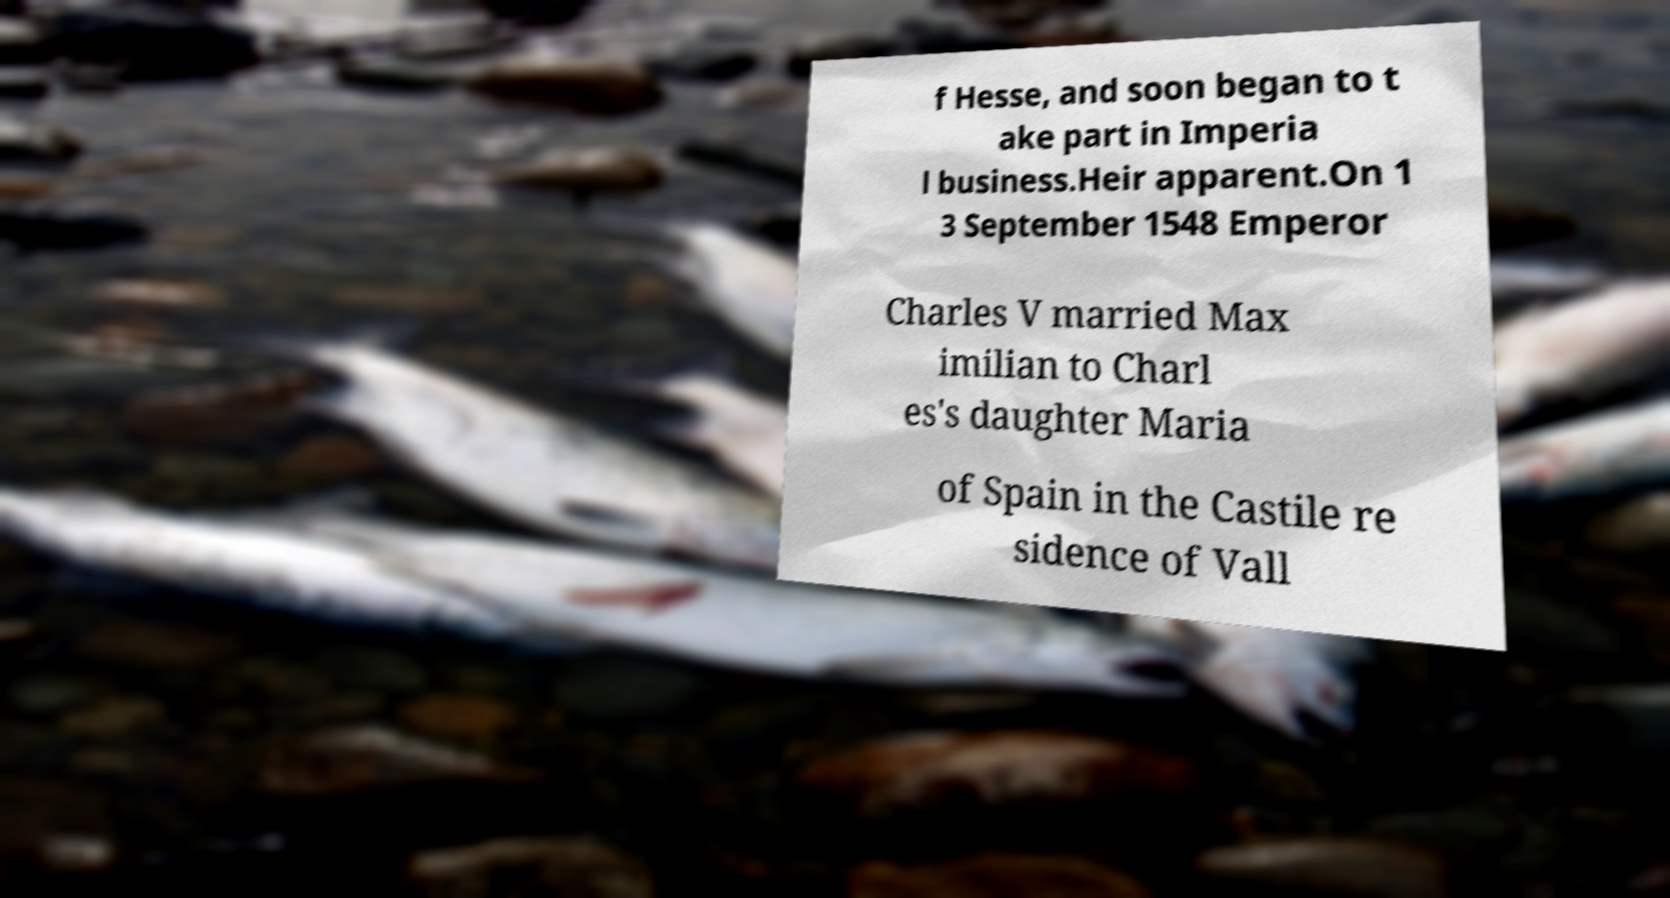Can you accurately transcribe the text from the provided image for me? f Hesse, and soon began to t ake part in Imperia l business.Heir apparent.On 1 3 September 1548 Emperor Charles V married Max imilian to Charl es's daughter Maria of Spain in the Castile re sidence of Vall 